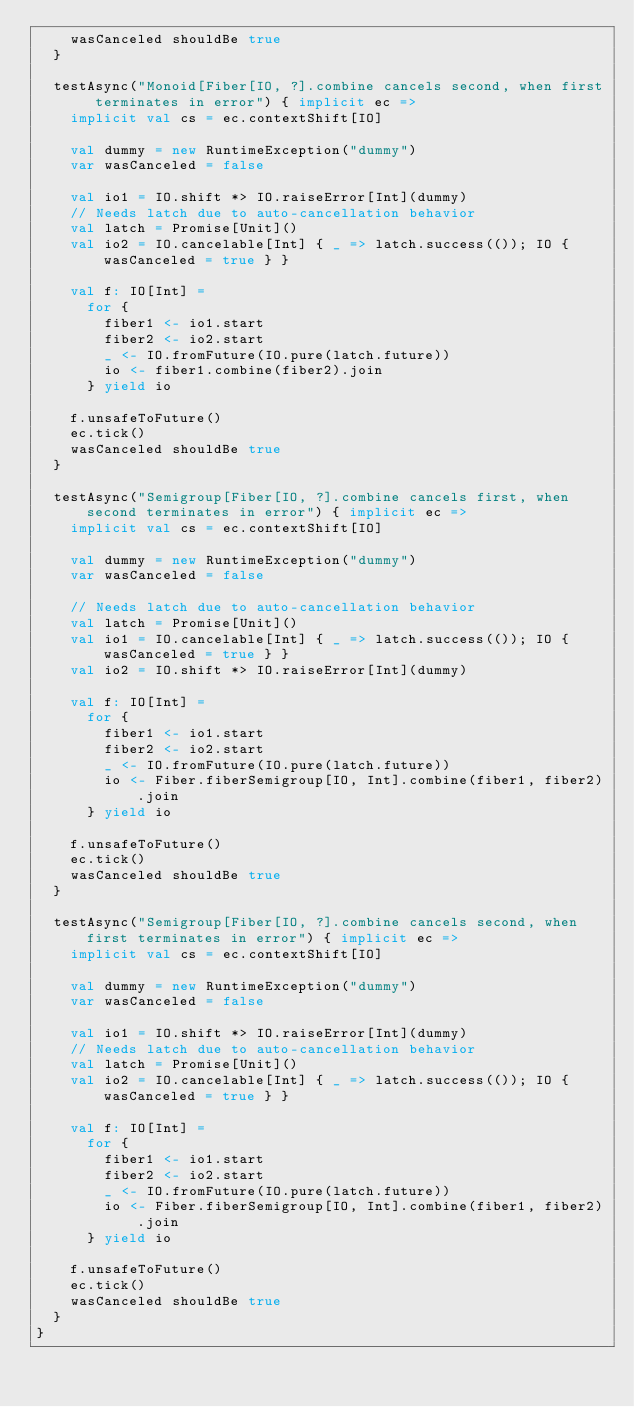<code> <loc_0><loc_0><loc_500><loc_500><_Scala_>    wasCanceled shouldBe true
  }

  testAsync("Monoid[Fiber[IO, ?].combine cancels second, when first terminates in error") { implicit ec =>
    implicit val cs = ec.contextShift[IO]

    val dummy = new RuntimeException("dummy")
    var wasCanceled = false

    val io1 = IO.shift *> IO.raiseError[Int](dummy)
    // Needs latch due to auto-cancellation behavior
    val latch = Promise[Unit]()
    val io2 = IO.cancelable[Int] { _ => latch.success(()); IO { wasCanceled = true } }

    val f: IO[Int] =
      for {
        fiber1 <- io1.start
        fiber2 <- io2.start
        _ <- IO.fromFuture(IO.pure(latch.future))
        io <- fiber1.combine(fiber2).join
      } yield io

    f.unsafeToFuture()
    ec.tick()
    wasCanceled shouldBe true
  }

  testAsync("Semigroup[Fiber[IO, ?].combine cancels first, when second terminates in error") { implicit ec =>
    implicit val cs = ec.contextShift[IO]

    val dummy = new RuntimeException("dummy")
    var wasCanceled = false

    // Needs latch due to auto-cancellation behavior
    val latch = Promise[Unit]()
    val io1 = IO.cancelable[Int] { _ => latch.success(()); IO { wasCanceled = true } }
    val io2 = IO.shift *> IO.raiseError[Int](dummy)

    val f: IO[Int] =
      for {
        fiber1 <- io1.start
        fiber2 <- io2.start
        _ <- IO.fromFuture(IO.pure(latch.future))
        io <- Fiber.fiberSemigroup[IO, Int].combine(fiber1, fiber2).join
      } yield io

    f.unsafeToFuture()
    ec.tick()
    wasCanceled shouldBe true
  }

  testAsync("Semigroup[Fiber[IO, ?].combine cancels second, when first terminates in error") { implicit ec =>
    implicit val cs = ec.contextShift[IO]

    val dummy = new RuntimeException("dummy")
    var wasCanceled = false

    val io1 = IO.shift *> IO.raiseError[Int](dummy)
    // Needs latch due to auto-cancellation behavior
    val latch = Promise[Unit]()
    val io2 = IO.cancelable[Int] { _ => latch.success(()); IO { wasCanceled = true } }

    val f: IO[Int] =
      for {
        fiber1 <- io1.start
        fiber2 <- io2.start
        _ <- IO.fromFuture(IO.pure(latch.future))
        io <- Fiber.fiberSemigroup[IO, Int].combine(fiber1, fiber2).join
      } yield io

    f.unsafeToFuture()
    ec.tick()
    wasCanceled shouldBe true
  }
}
</code> 